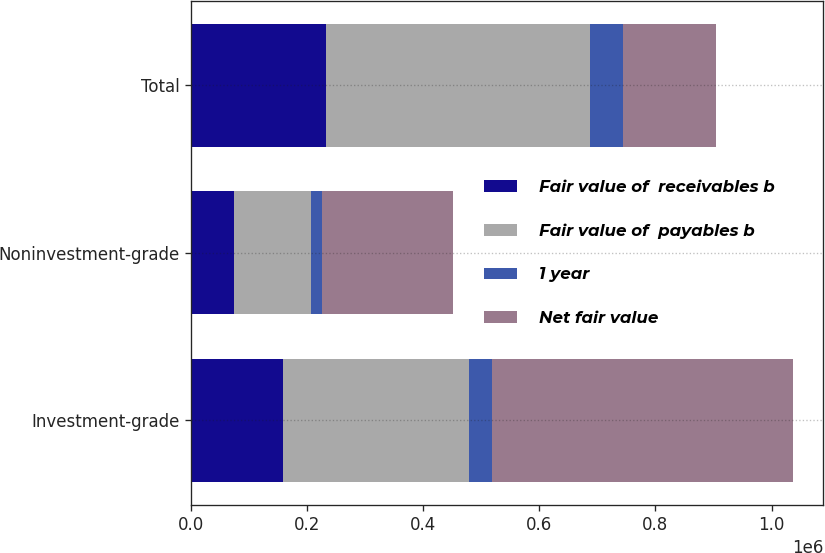<chart> <loc_0><loc_0><loc_500><loc_500><stacked_bar_chart><ecel><fcel>Investment-grade<fcel>Noninvestment-grade<fcel>Total<nl><fcel>Fair value of  receivables b<fcel>159286<fcel>73394<fcel>232680<nl><fcel>Fair value of  payables b<fcel>319726<fcel>134125<fcel>453851<nl><fcel>1 year<fcel>39429<fcel>18439<fcel>57868<nl><fcel>Net fair value<fcel>518441<fcel>225958<fcel>159286<nl></chart> 